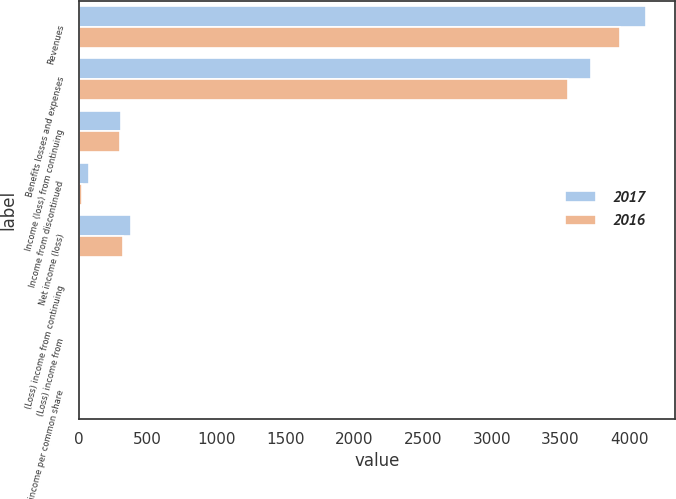Convert chart to OTSL. <chart><loc_0><loc_0><loc_500><loc_500><stacked_bar_chart><ecel><fcel>Revenues<fcel>Benefits losses and expenses<fcel>Income (loss) from continuing<fcel>Income from discontinued<fcel>Net income (loss)<fcel>(Loss) income from continuing<fcel>(Loss) income from<fcel>Net income per common share<nl><fcel>2017<fcel>4123<fcel>3722<fcel>303<fcel>75<fcel>378<fcel>0.82<fcel>0.2<fcel>1.02<nl><fcel>2016<fcel>3930<fcel>3556<fcel>298<fcel>25<fcel>323<fcel>0.75<fcel>0.06<fcel>0.81<nl></chart> 